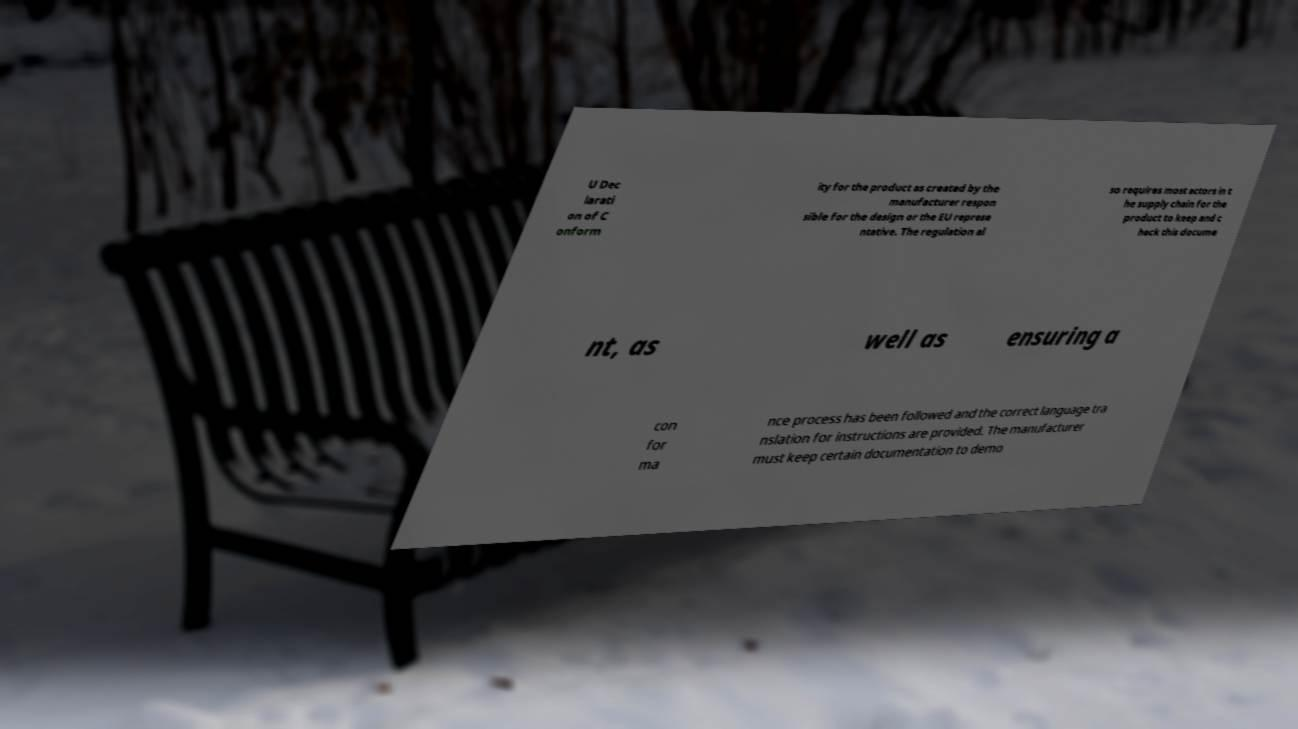Can you read and provide the text displayed in the image?This photo seems to have some interesting text. Can you extract and type it out for me? U Dec larati on of C onform ity for the product as created by the manufacturer respon sible for the design or the EU represe ntative. The regulation al so requires most actors in t he supply chain for the product to keep and c heck this docume nt, as well as ensuring a con for ma nce process has been followed and the correct language tra nslation for instructions are provided. The manufacturer must keep certain documentation to demo 